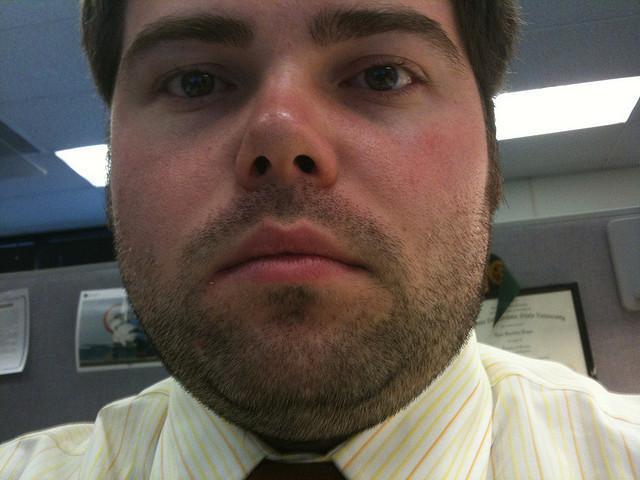How many cats are sleeping in the picture?
Give a very brief answer. 0. 